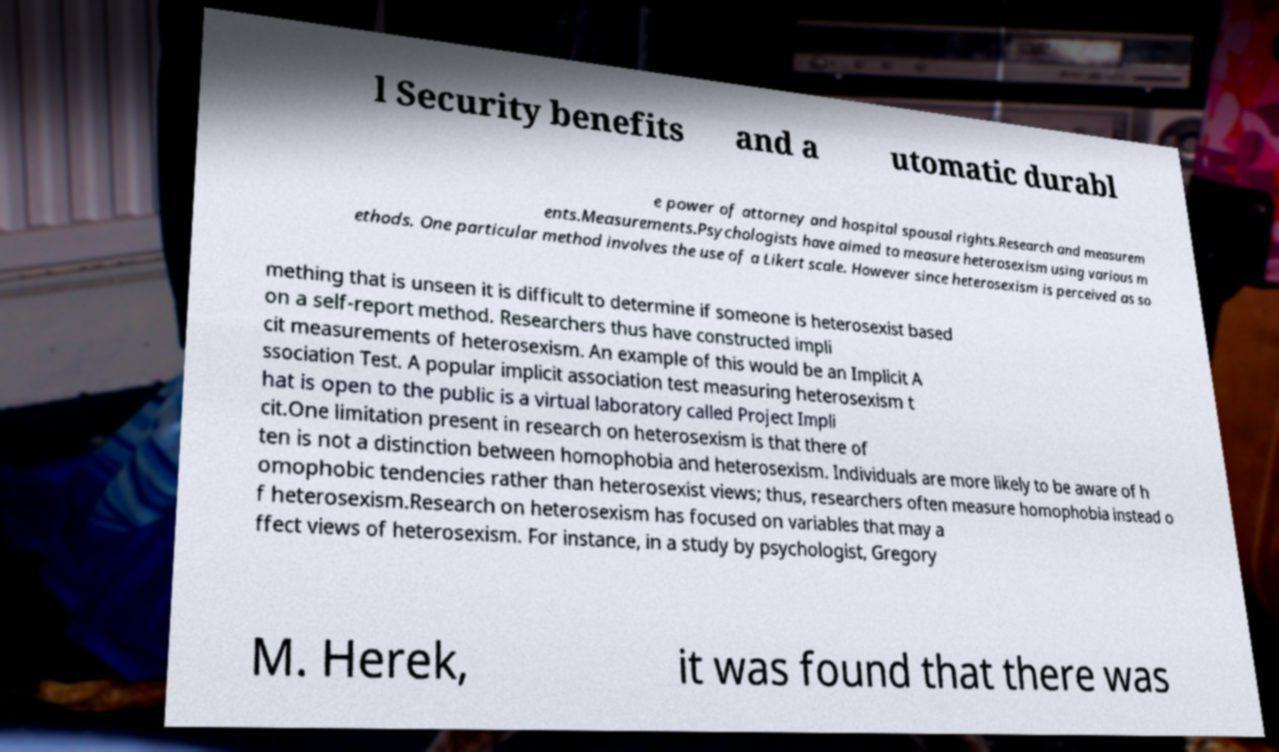Could you assist in decoding the text presented in this image and type it out clearly? l Security benefits and a utomatic durabl e power of attorney and hospital spousal rights.Research and measurem ents.Measurements.Psychologists have aimed to measure heterosexism using various m ethods. One particular method involves the use of a Likert scale. However since heterosexism is perceived as so mething that is unseen it is difficult to determine if someone is heterosexist based on a self-report method. Researchers thus have constructed impli cit measurements of heterosexism. An example of this would be an Implicit A ssociation Test. A popular implicit association test measuring heterosexism t hat is open to the public is a virtual laboratory called Project Impli cit.One limitation present in research on heterosexism is that there of ten is not a distinction between homophobia and heterosexism. Individuals are more likely to be aware of h omophobic tendencies rather than heterosexist views; thus, researchers often measure homophobia instead o f heterosexism.Research on heterosexism has focused on variables that may a ffect views of heterosexism. For instance, in a study by psychologist, Gregory M. Herek, it was found that there was 